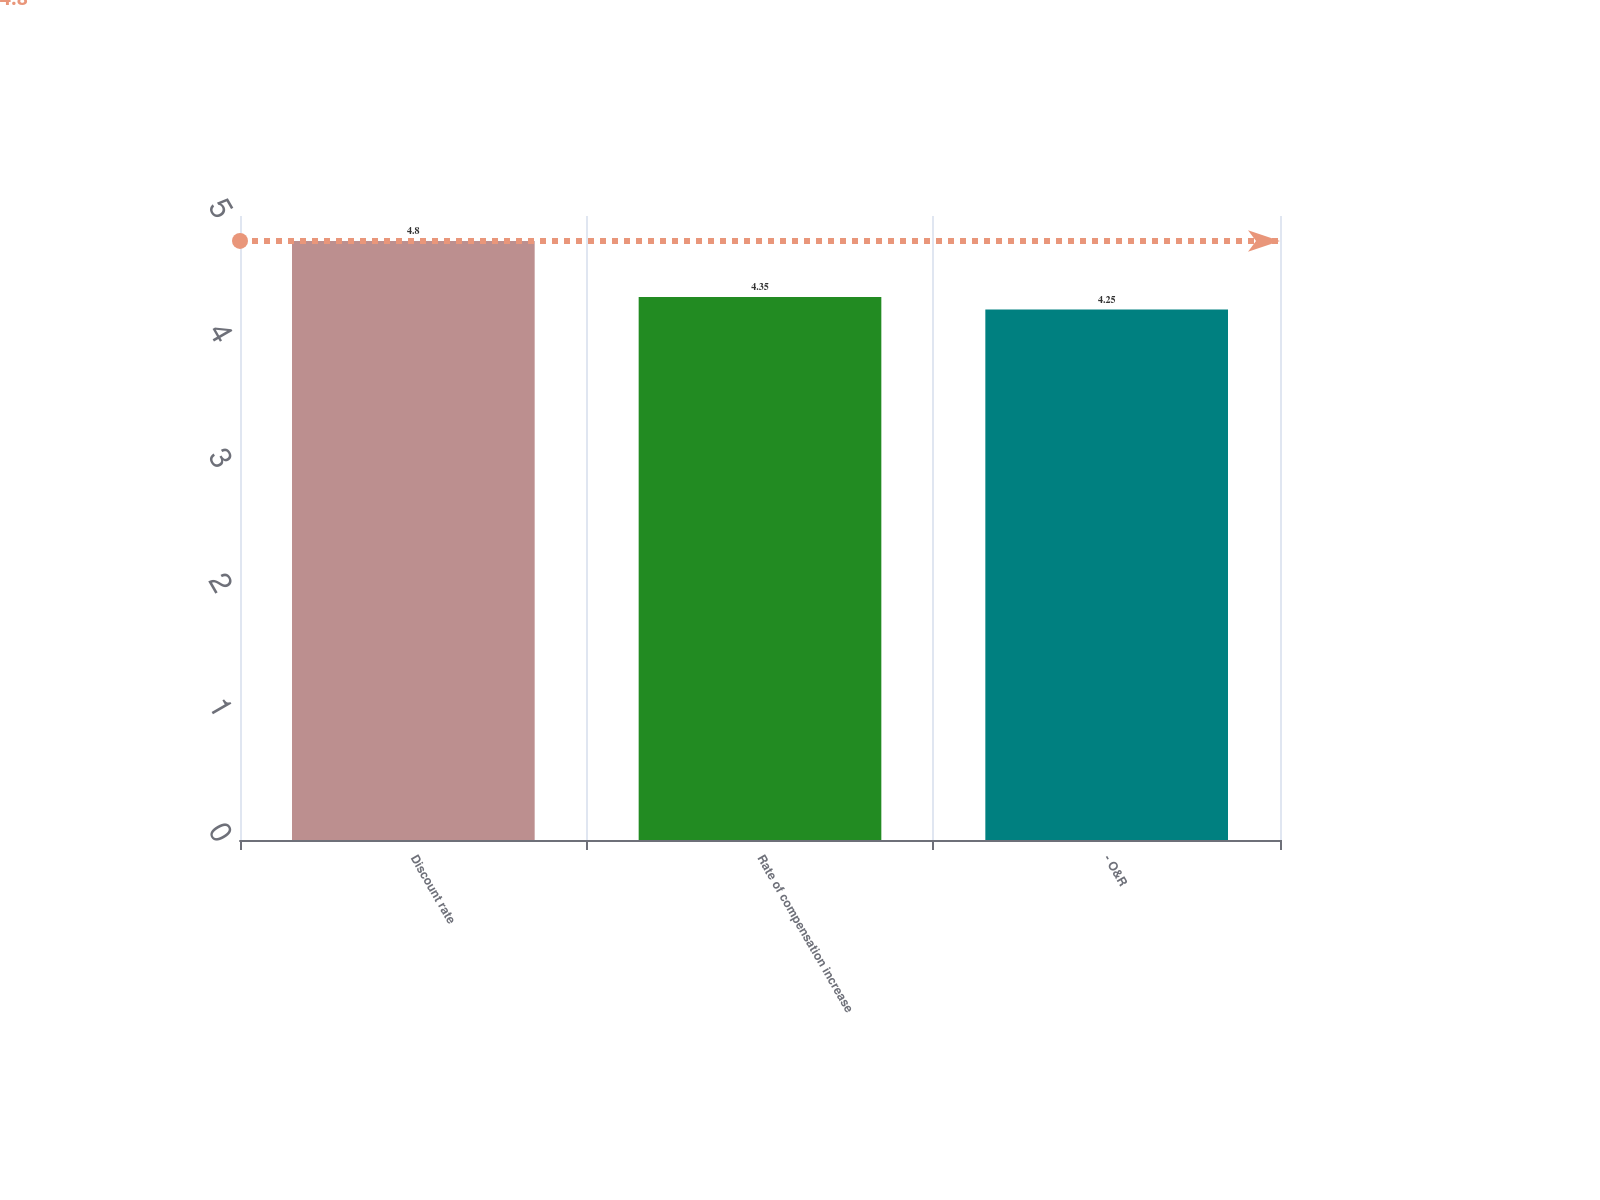<chart> <loc_0><loc_0><loc_500><loc_500><bar_chart><fcel>Discount rate<fcel>Rate of compensation increase<fcel>- O&R<nl><fcel>4.8<fcel>4.35<fcel>4.25<nl></chart> 